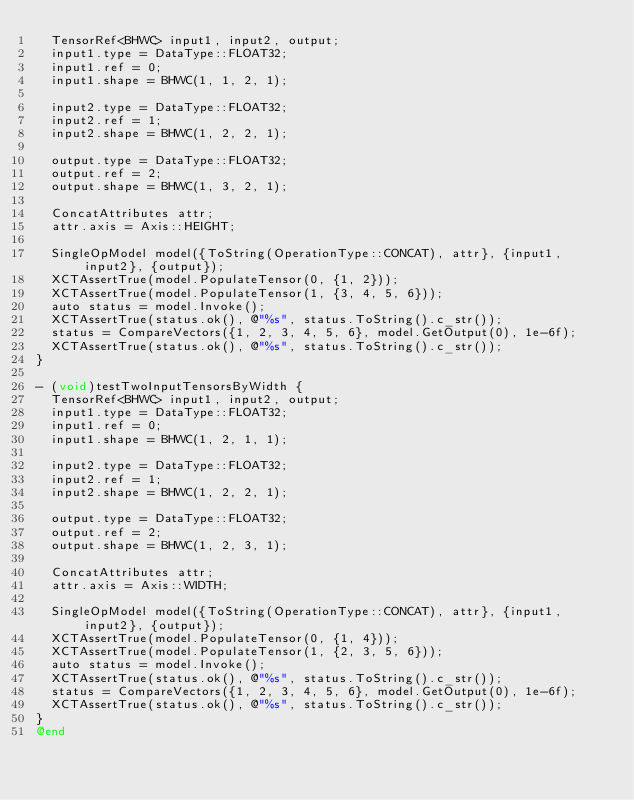<code> <loc_0><loc_0><loc_500><loc_500><_ObjectiveC_>  TensorRef<BHWC> input1, input2, output;
  input1.type = DataType::FLOAT32;
  input1.ref = 0;
  input1.shape = BHWC(1, 1, 2, 1);

  input2.type = DataType::FLOAT32;
  input2.ref = 1;
  input2.shape = BHWC(1, 2, 2, 1);

  output.type = DataType::FLOAT32;
  output.ref = 2;
  output.shape = BHWC(1, 3, 2, 1);

  ConcatAttributes attr;
  attr.axis = Axis::HEIGHT;

  SingleOpModel model({ToString(OperationType::CONCAT), attr}, {input1, input2}, {output});
  XCTAssertTrue(model.PopulateTensor(0, {1, 2}));
  XCTAssertTrue(model.PopulateTensor(1, {3, 4, 5, 6}));
  auto status = model.Invoke();
  XCTAssertTrue(status.ok(), @"%s", status.ToString().c_str());
  status = CompareVectors({1, 2, 3, 4, 5, 6}, model.GetOutput(0), 1e-6f);
  XCTAssertTrue(status.ok(), @"%s", status.ToString().c_str());
}

- (void)testTwoInputTensorsByWidth {
  TensorRef<BHWC> input1, input2, output;
  input1.type = DataType::FLOAT32;
  input1.ref = 0;
  input1.shape = BHWC(1, 2, 1, 1);

  input2.type = DataType::FLOAT32;
  input2.ref = 1;
  input2.shape = BHWC(1, 2, 2, 1);

  output.type = DataType::FLOAT32;
  output.ref = 2;
  output.shape = BHWC(1, 2, 3, 1);

  ConcatAttributes attr;
  attr.axis = Axis::WIDTH;

  SingleOpModel model({ToString(OperationType::CONCAT), attr}, {input1, input2}, {output});
  XCTAssertTrue(model.PopulateTensor(0, {1, 4}));
  XCTAssertTrue(model.PopulateTensor(1, {2, 3, 5, 6}));
  auto status = model.Invoke();
  XCTAssertTrue(status.ok(), @"%s", status.ToString().c_str());
  status = CompareVectors({1, 2, 3, 4, 5, 6}, model.GetOutput(0), 1e-6f);
  XCTAssertTrue(status.ok(), @"%s", status.ToString().c_str());
}
@end
</code> 